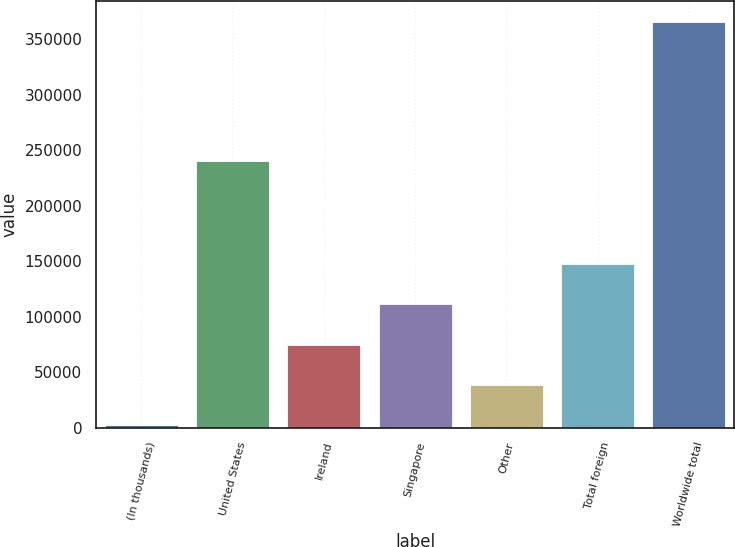Convert chart. <chart><loc_0><loc_0><loc_500><loc_500><bar_chart><fcel>(In thousands)<fcel>United States<fcel>Ireland<fcel>Singapore<fcel>Other<fcel>Total foreign<fcel>Worldwide total<nl><fcel>2013<fcel>240429<fcel>74747.8<fcel>111115<fcel>38380.4<fcel>147483<fcel>365687<nl></chart> 